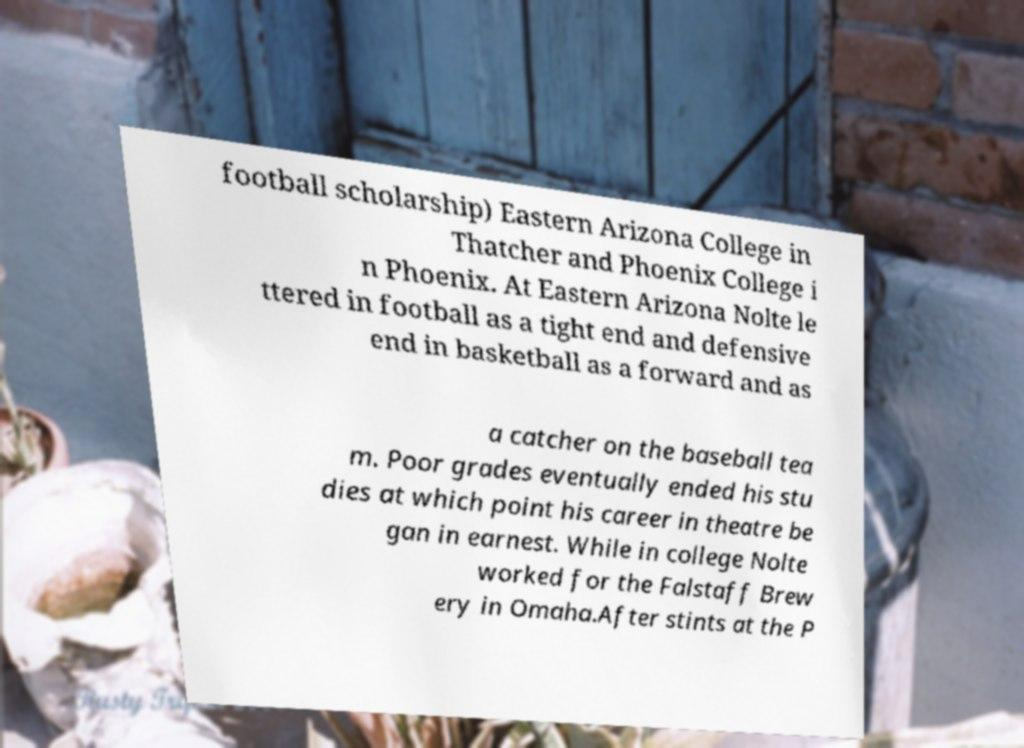For documentation purposes, I need the text within this image transcribed. Could you provide that? football scholarship) Eastern Arizona College in Thatcher and Phoenix College i n Phoenix. At Eastern Arizona Nolte le ttered in football as a tight end and defensive end in basketball as a forward and as a catcher on the baseball tea m. Poor grades eventually ended his stu dies at which point his career in theatre be gan in earnest. While in college Nolte worked for the Falstaff Brew ery in Omaha.After stints at the P 